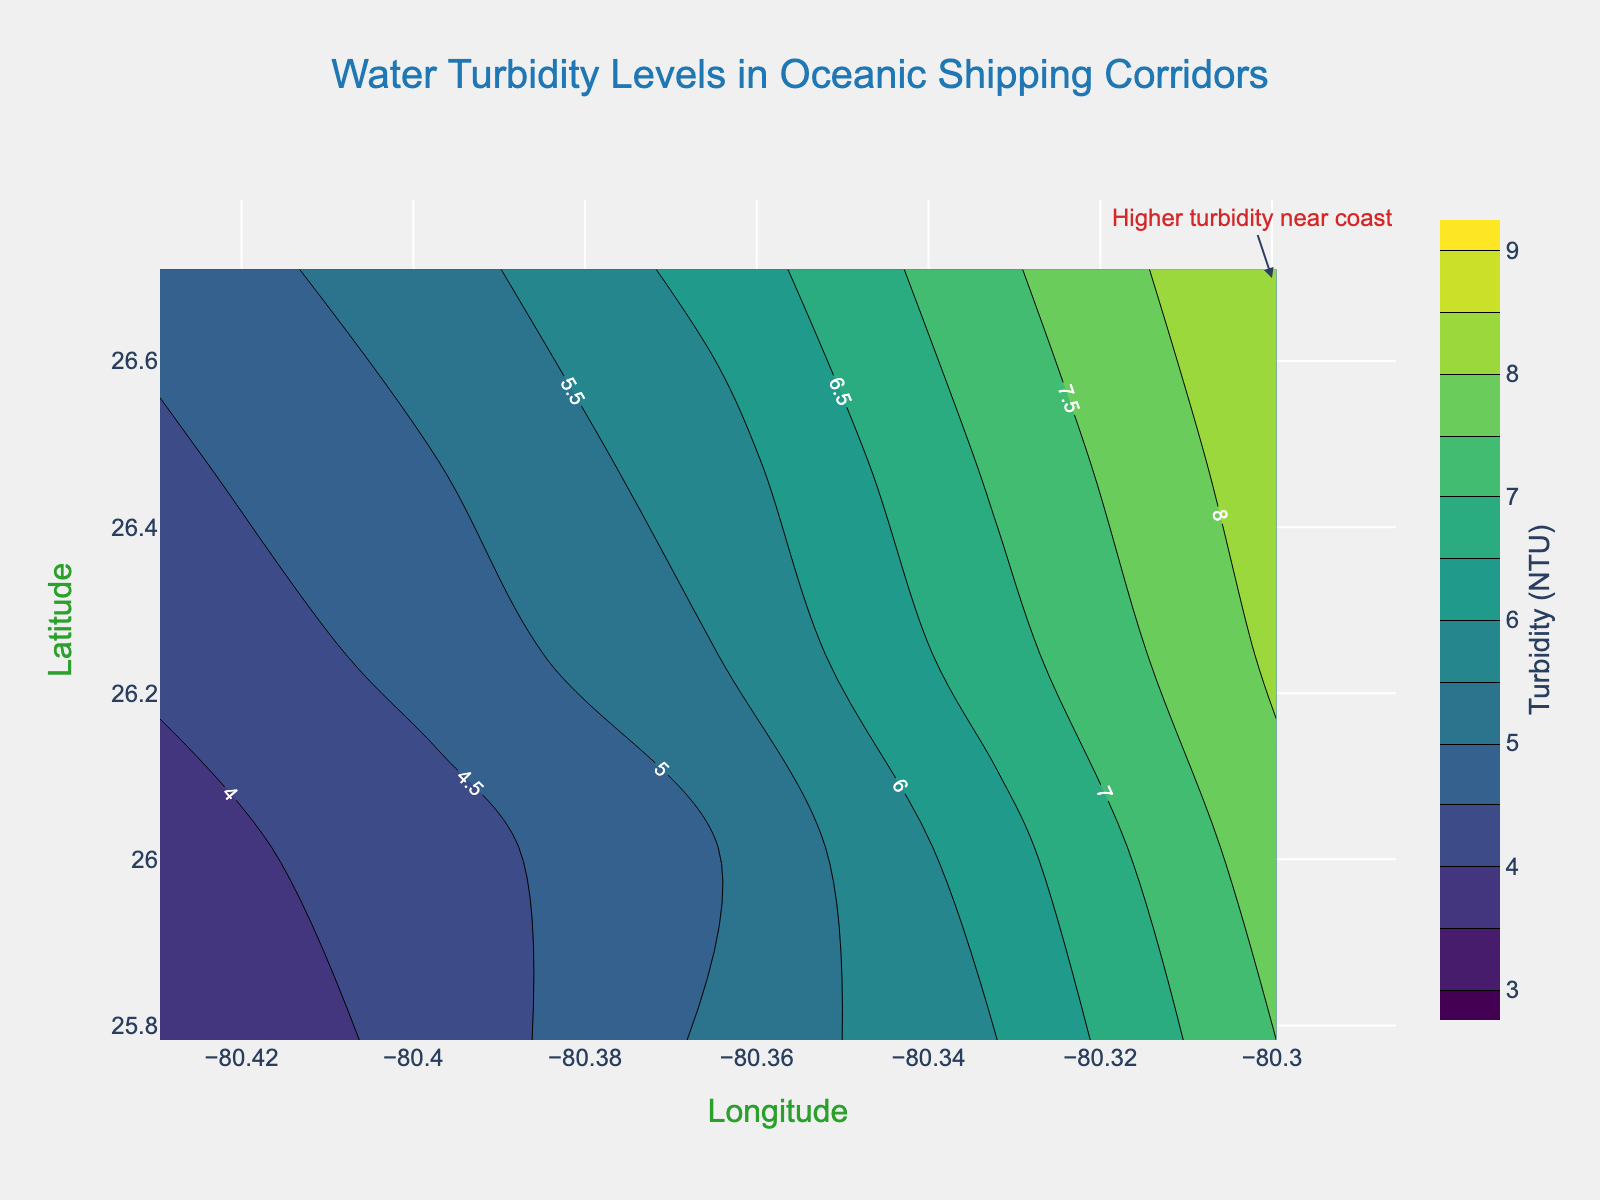What is the title of the contour plot? The title is located at the top center of the plot and is prominently displayed in a larger font.
Answer: Water Turbidity Levels in Oceanic Shipping Corridors What are the ranges of latitude and longitude in the plot? The latitude and longitude ranges are indicated by the axis labels on the x (longitude) and y (latitude) axes.
Answer: Latitude: 25.7825 to 26.7105, Longitude: -80.4295 to -80.2995 What is the color indicating the lowest turbidity level? The color associated with the lowest turbidity level can be inferred from the color bar on the right side of the plot, which uses a Viridis color scale. The lowest value is 3 NTU, located at the start of the color bar.
Answer: Dark purple How does the turbidity level change as we move from west to east along latitude 26.0145? By examining the turbidity values from the contour lines at latitude 26.0145 and moving from west (longitude -80.4295) to east (longitude -80.2995), we can see the trend in turbidity levels.
Answer: It increases Which region shows the highest turbidity value? The highest turbidity value can be identified by locating the contour line labeled with the highest numerical value on the plot.
Answer: Near latitude 26.7105 and longitude -80.2995 Compare the turbidity levels at latitude 26.4785 and longitude -80.3645 with latitude 25.7825 and longitude -80.2995. By examining the specific points on the plot, we can compare turbidity levels at these coordinates. The contour labels help identify the exact values.
Answer: 5.8 NTU (26.4785, -80.3645) vs. 7.5 NTU (25.7825, -80.2995) What is the trend in turbidity levels moving from latitude 25.7825 to 26.7105 along longitude -80.2995? Look at the contour lines along the longitude -80.2995 from north to south and note the turbidity values to find the trend.
Answer: Turbidity levels increase What does the annotation "Higher turbidity near coast" refer to? The annotation with an arrow points to a specific region on the map; by following the annotation, we can interpret its meaning.
Answer: It refers to the higher turbidity levels near the eastern edge of the plot, close to the coastline Is the increase in turbidity more significant from latitude 25.7825 to 26.7145 or longitude -80.4295 to -80.2995? By comparing the changes in turbidity levels along both the latitude and longitude directions using the contour lines, we can determine which direction shows a more significant increase.
Answer: Latitude 25.7825 to 26.7145 Identify an area where turbidity does not fluctuate much. Find a region on the plot where the contour lines are spaced wide apart uniformly, indicating relatively stable turbidity levels.
Answer: Around latitude 26.0145 and longitude -80.4295 